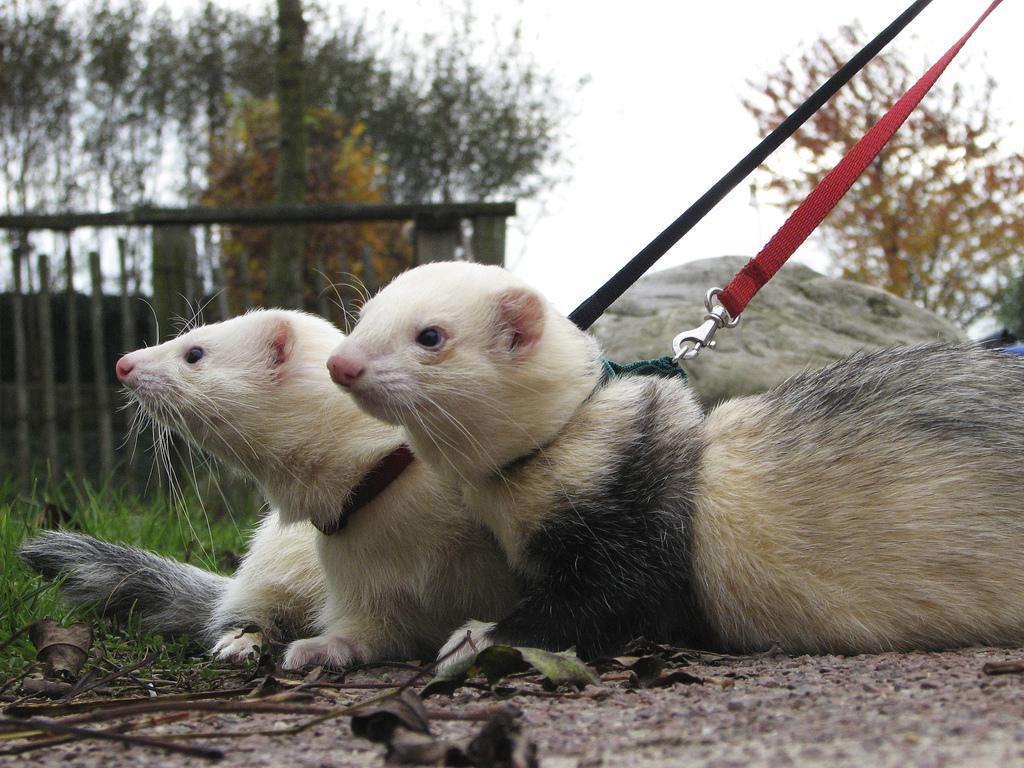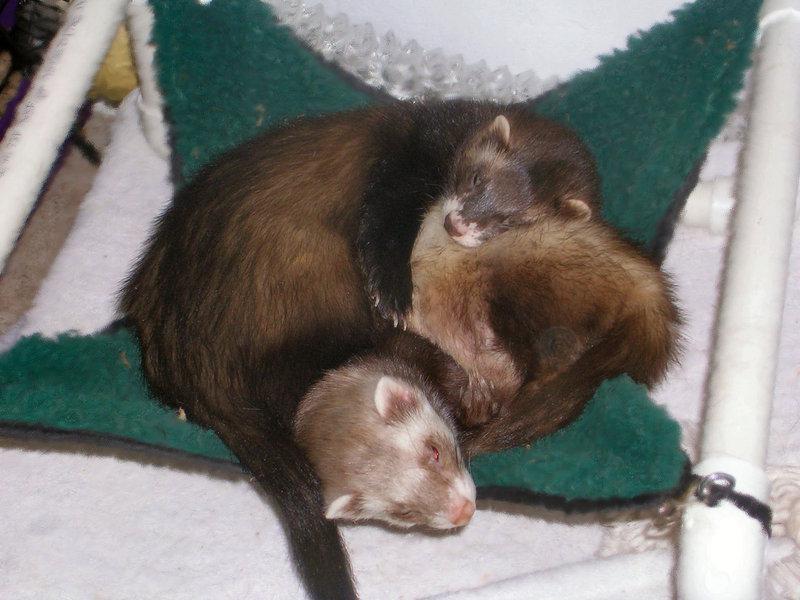The first image is the image on the left, the second image is the image on the right. For the images displayed, is the sentence "An image contains a human holding two ferrets." factually correct? Answer yes or no. No. 